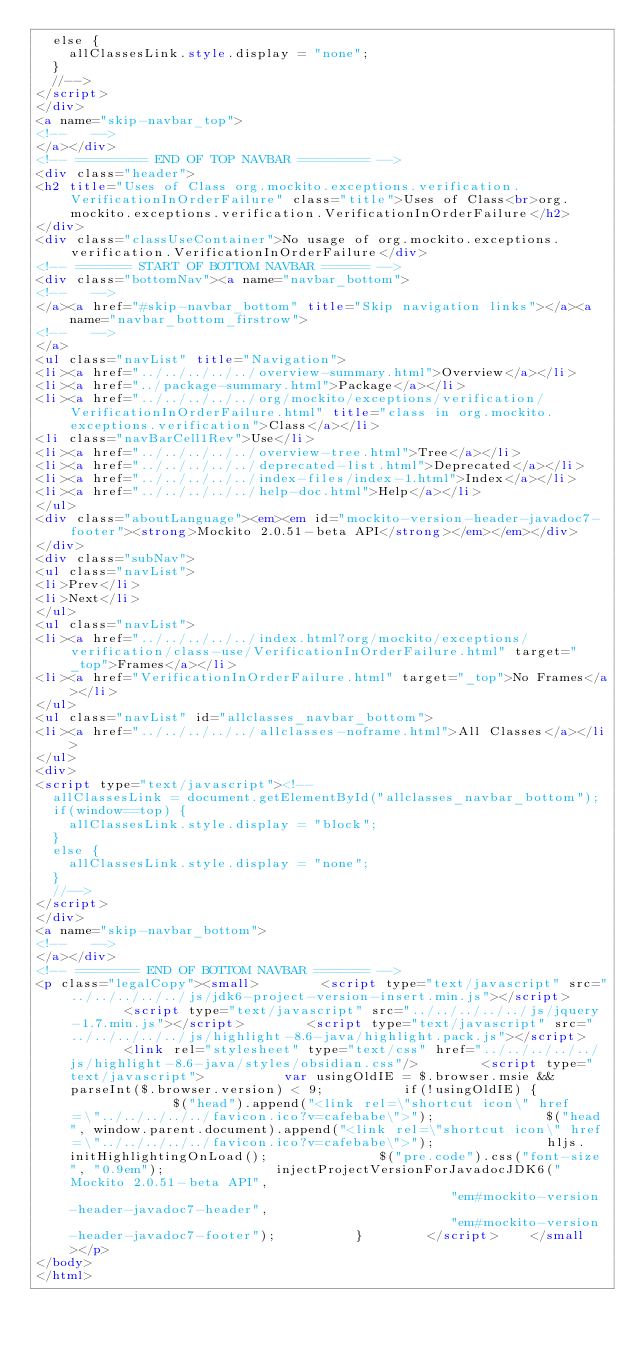<code> <loc_0><loc_0><loc_500><loc_500><_HTML_>  else {
    allClassesLink.style.display = "none";
  }
  //-->
</script>
</div>
<a name="skip-navbar_top">
<!--   -->
</a></div>
<!-- ========= END OF TOP NAVBAR ========= -->
<div class="header">
<h2 title="Uses of Class org.mockito.exceptions.verification.VerificationInOrderFailure" class="title">Uses of Class<br>org.mockito.exceptions.verification.VerificationInOrderFailure</h2>
</div>
<div class="classUseContainer">No usage of org.mockito.exceptions.verification.VerificationInOrderFailure</div>
<!-- ======= START OF BOTTOM NAVBAR ====== -->
<div class="bottomNav"><a name="navbar_bottom">
<!--   -->
</a><a href="#skip-navbar_bottom" title="Skip navigation links"></a><a name="navbar_bottom_firstrow">
<!--   -->
</a>
<ul class="navList" title="Navigation">
<li><a href="../../../../../overview-summary.html">Overview</a></li>
<li><a href="../package-summary.html">Package</a></li>
<li><a href="../../../../../org/mockito/exceptions/verification/VerificationInOrderFailure.html" title="class in org.mockito.exceptions.verification">Class</a></li>
<li class="navBarCell1Rev">Use</li>
<li><a href="../../../../../overview-tree.html">Tree</a></li>
<li><a href="../../../../../deprecated-list.html">Deprecated</a></li>
<li><a href="../../../../../index-files/index-1.html">Index</a></li>
<li><a href="../../../../../help-doc.html">Help</a></li>
</ul>
<div class="aboutLanguage"><em><em id="mockito-version-header-javadoc7-footer"><strong>Mockito 2.0.51-beta API</strong></em></em></div>
</div>
<div class="subNav">
<ul class="navList">
<li>Prev</li>
<li>Next</li>
</ul>
<ul class="navList">
<li><a href="../../../../../index.html?org/mockito/exceptions/verification/class-use/VerificationInOrderFailure.html" target="_top">Frames</a></li>
<li><a href="VerificationInOrderFailure.html" target="_top">No Frames</a></li>
</ul>
<ul class="navList" id="allclasses_navbar_bottom">
<li><a href="../../../../../allclasses-noframe.html">All Classes</a></li>
</ul>
<div>
<script type="text/javascript"><!--
  allClassesLink = document.getElementById("allclasses_navbar_bottom");
  if(window==top) {
    allClassesLink.style.display = "block";
  }
  else {
    allClassesLink.style.display = "none";
  }
  //-->
</script>
</div>
<a name="skip-navbar_bottom">
<!--   -->
</a></div>
<!-- ======== END OF BOTTOM NAVBAR ======= -->
<p class="legalCopy"><small>        <script type="text/javascript" src="../../../../../js/jdk6-project-version-insert.min.js"></script>        <script type="text/javascript" src="../../../../../js/jquery-1.7.min.js"></script>        <script type="text/javascript" src="../../../../../js/highlight-8.6-java/highlight.pack.js"></script>        <link rel="stylesheet" type="text/css" href="../../../../../js/highlight-8.6-java/styles/obsidian.css"/>        <script type="text/javascript">          var usingOldIE = $.browser.msie && parseInt($.browser.version) < 9;          if(!usingOldIE) {              $("head").append("<link rel=\"shortcut icon\" href=\"../../../../../favicon.ico?v=cafebabe\">");              $("head", window.parent.document).append("<link rel=\"shortcut icon\" href=\"../../../../../favicon.ico?v=cafebabe\">");              hljs.initHighlightingOnLoad();              $("pre.code").css("font-size", "0.9em");              injectProjectVersionForJavadocJDK6("Mockito 2.0.51-beta API",                                                 "em#mockito-version-header-javadoc7-header",                                                 "em#mockito-version-header-javadoc7-footer");          }        </script>    </small></p>
</body>
</html>
</code> 